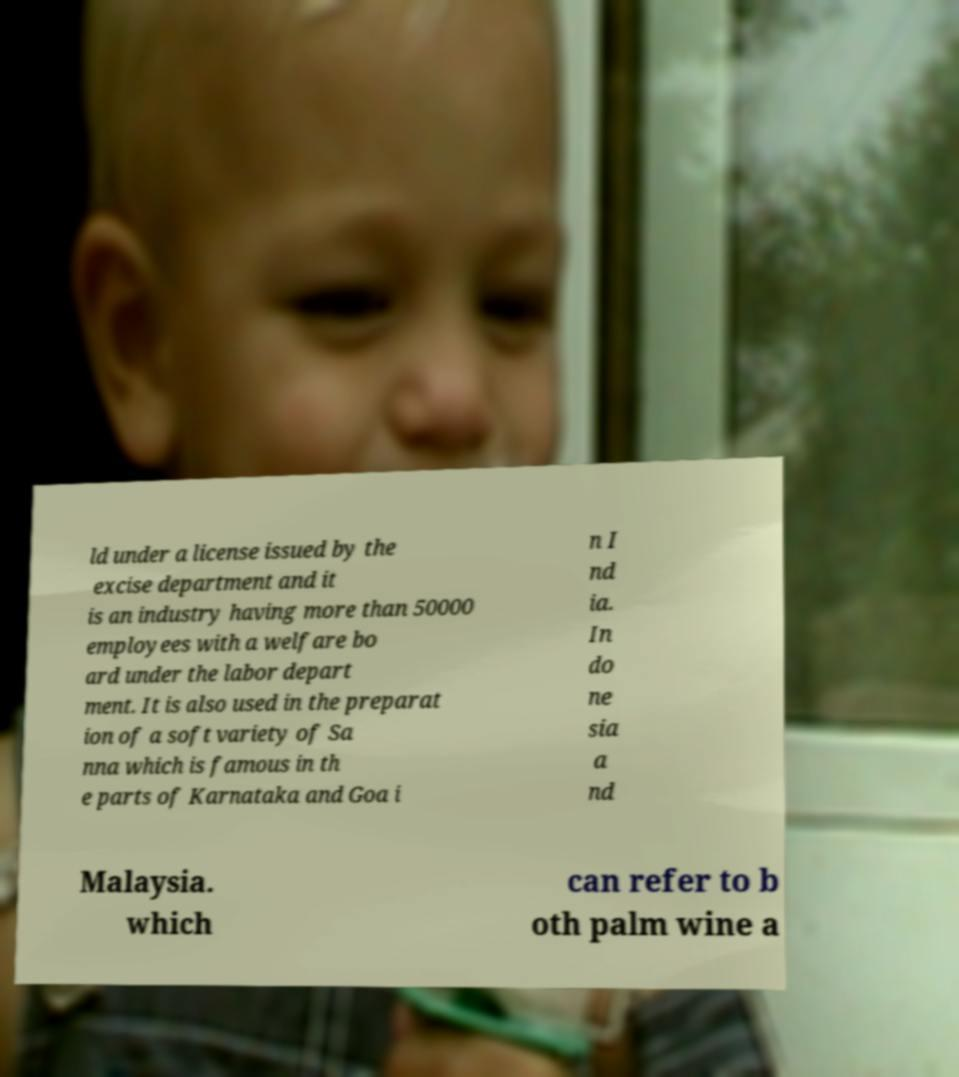Please identify and transcribe the text found in this image. ld under a license issued by the excise department and it is an industry having more than 50000 employees with a welfare bo ard under the labor depart ment. It is also used in the preparat ion of a soft variety of Sa nna which is famous in th e parts of Karnataka and Goa i n I nd ia. In do ne sia a nd Malaysia. which can refer to b oth palm wine a 